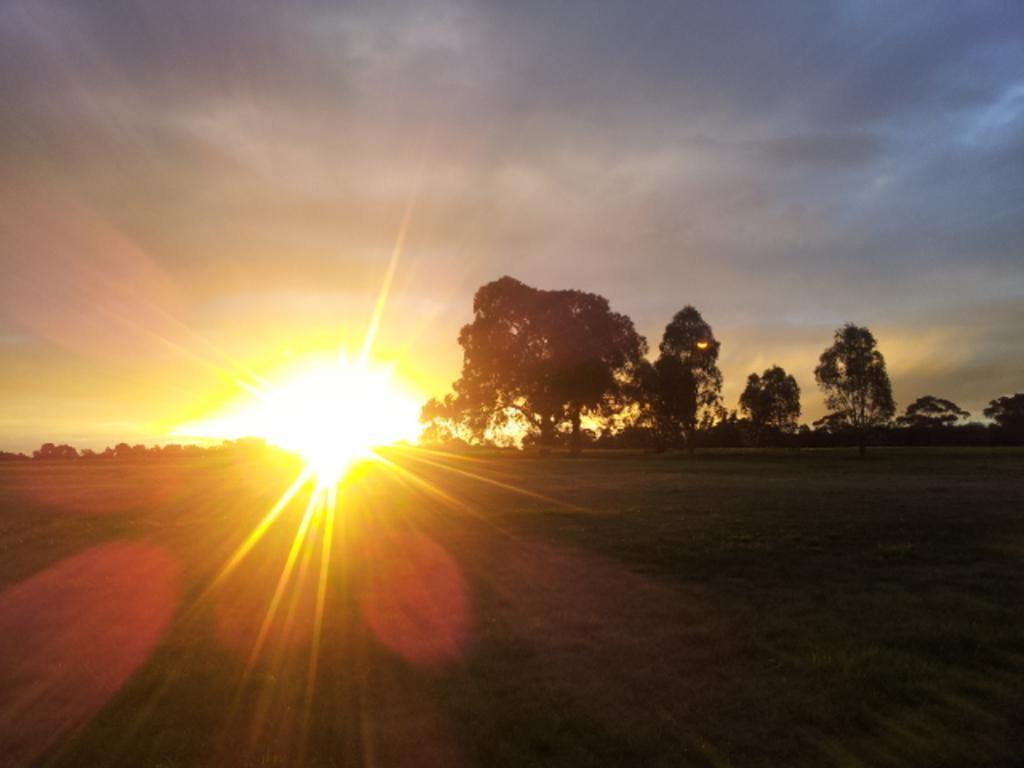Please provide a concise description of this image. In this image, we can see the sun rising in the sky. There are some trees in the middle of the image. 